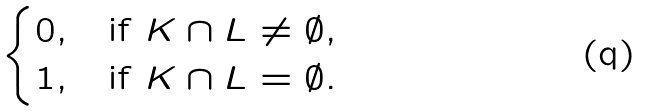Convert formula to latex. <formula><loc_0><loc_0><loc_500><loc_500>\begin{cases} 0 , & \text {if $K \cap L \neq \emptyset$} , \\ 1 , & \text {if $K \cap L = \emptyset $} . \end{cases}</formula> 